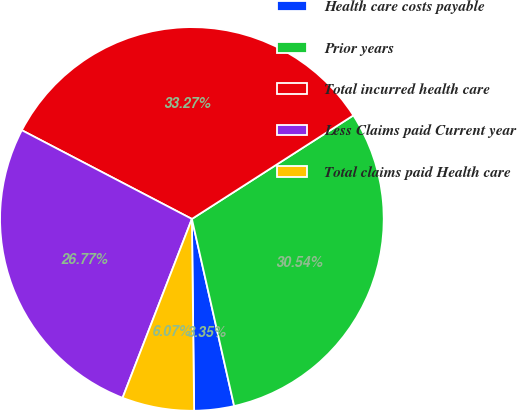Convert chart. <chart><loc_0><loc_0><loc_500><loc_500><pie_chart><fcel>Health care costs payable<fcel>Prior years<fcel>Total incurred health care<fcel>Less Claims paid Current year<fcel>Total claims paid Health care<nl><fcel>3.35%<fcel>30.54%<fcel>33.27%<fcel>26.77%<fcel>6.07%<nl></chart> 